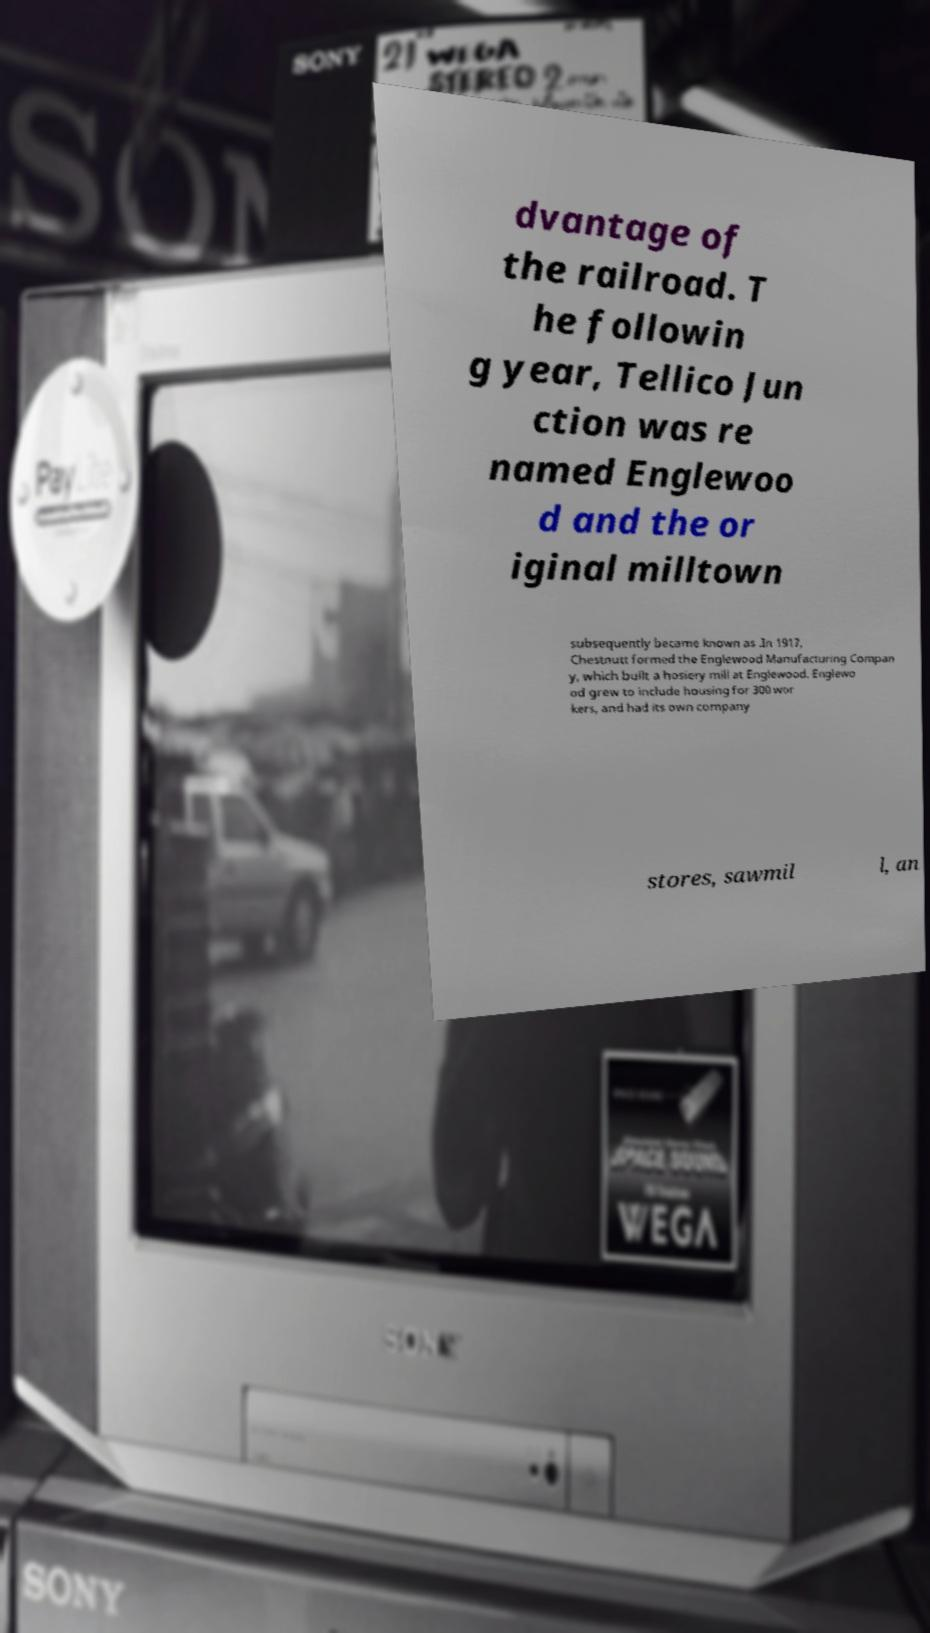Please read and relay the text visible in this image. What does it say? dvantage of the railroad. T he followin g year, Tellico Jun ction was re named Englewoo d and the or iginal milltown subsequently became known as .In 1917, Chestnutt formed the Englewood Manufacturing Compan y, which built a hosiery mill at Englewood. Englewo od grew to include housing for 300 wor kers, and had its own company stores, sawmil l, an 